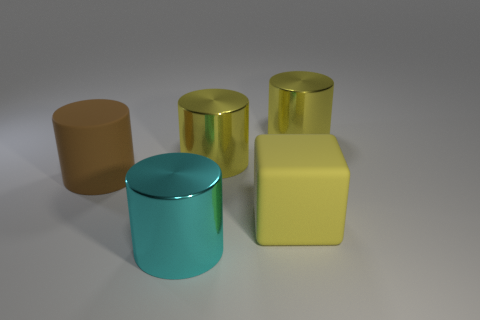Subtract all brown matte cylinders. How many cylinders are left? 3 Subtract all purple cubes. How many yellow cylinders are left? 2 Add 3 big rubber things. How many objects exist? 8 Subtract all cyan cylinders. How many cylinders are left? 3 Subtract all cylinders. How many objects are left? 1 Subtract 2 cylinders. How many cylinders are left? 2 Subtract all gray cylinders. Subtract all blue cubes. How many cylinders are left? 4 Add 4 big metal cylinders. How many big metal cylinders exist? 7 Subtract 2 yellow cylinders. How many objects are left? 3 Subtract all large cyan objects. Subtract all blue shiny spheres. How many objects are left? 4 